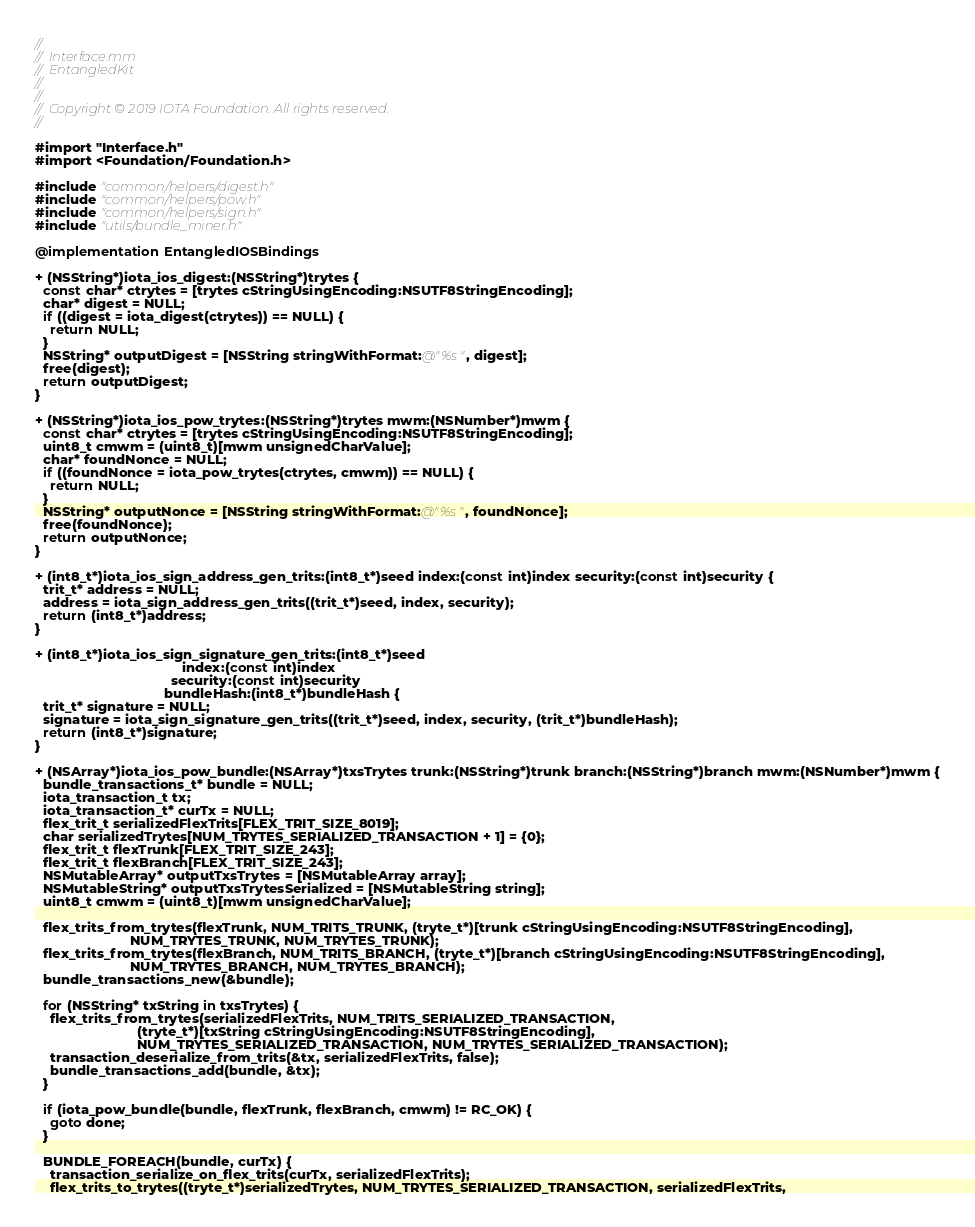<code> <loc_0><loc_0><loc_500><loc_500><_ObjectiveC_>//
//  Interface.mm
//  EntangledKit
//
//
//  Copyright © 2019 IOTA Foundation. All rights reserved.
//

#import "Interface.h"
#import <Foundation/Foundation.h>

#include "common/helpers/digest.h"
#include "common/helpers/pow.h"
#include "common/helpers/sign.h"
#include "utils/bundle_miner.h"

@implementation EntangledIOSBindings

+ (NSString*)iota_ios_digest:(NSString*)trytes {
  const char* ctrytes = [trytes cStringUsingEncoding:NSUTF8StringEncoding];
  char* digest = NULL;
  if ((digest = iota_digest(ctrytes)) == NULL) {
    return NULL;
  }
  NSString* outputDigest = [NSString stringWithFormat:@"%s", digest];
  free(digest);
  return outputDigest;
}

+ (NSString*)iota_ios_pow_trytes:(NSString*)trytes mwm:(NSNumber*)mwm {
  const char* ctrytes = [trytes cStringUsingEncoding:NSUTF8StringEncoding];
  uint8_t cmwm = (uint8_t)[mwm unsignedCharValue];
  char* foundNonce = NULL;
  if ((foundNonce = iota_pow_trytes(ctrytes, cmwm)) == NULL) {
    return NULL;
  }
  NSString* outputNonce = [NSString stringWithFormat:@"%s", foundNonce];
  free(foundNonce);
  return outputNonce;
}

+ (int8_t*)iota_ios_sign_address_gen_trits:(int8_t*)seed index:(const int)index security:(const int)security {
  trit_t* address = NULL;
  address = iota_sign_address_gen_trits((trit_t*)seed, index, security);
  return (int8_t*)address;
}

+ (int8_t*)iota_ios_sign_signature_gen_trits:(int8_t*)seed
                                       index:(const int)index
                                    security:(const int)security
                                  bundleHash:(int8_t*)bundleHash {
  trit_t* signature = NULL;
  signature = iota_sign_signature_gen_trits((trit_t*)seed, index, security, (trit_t*)bundleHash);
  return (int8_t*)signature;
}

+ (NSArray*)iota_ios_pow_bundle:(NSArray*)txsTrytes trunk:(NSString*)trunk branch:(NSString*)branch mwm:(NSNumber*)mwm {
  bundle_transactions_t* bundle = NULL;
  iota_transaction_t tx;
  iota_transaction_t* curTx = NULL;
  flex_trit_t serializedFlexTrits[FLEX_TRIT_SIZE_8019];
  char serializedTrytes[NUM_TRYTES_SERIALIZED_TRANSACTION + 1] = {0};
  flex_trit_t flexTrunk[FLEX_TRIT_SIZE_243];
  flex_trit_t flexBranch[FLEX_TRIT_SIZE_243];
  NSMutableArray* outputTxsTrytes = [NSMutableArray array];
  NSMutableString* outputTxsTrytesSerialized = [NSMutableString string];
  uint8_t cmwm = (uint8_t)[mwm unsignedCharValue];

  flex_trits_from_trytes(flexTrunk, NUM_TRITS_TRUNK, (tryte_t*)[trunk cStringUsingEncoding:NSUTF8StringEncoding],
                         NUM_TRYTES_TRUNK, NUM_TRYTES_TRUNK);
  flex_trits_from_trytes(flexBranch, NUM_TRITS_BRANCH, (tryte_t*)[branch cStringUsingEncoding:NSUTF8StringEncoding],
                         NUM_TRYTES_BRANCH, NUM_TRYTES_BRANCH);
  bundle_transactions_new(&bundle);

  for (NSString* txString in txsTrytes) {
    flex_trits_from_trytes(serializedFlexTrits, NUM_TRITS_SERIALIZED_TRANSACTION,
                           (tryte_t*)[txString cStringUsingEncoding:NSUTF8StringEncoding],
                           NUM_TRYTES_SERIALIZED_TRANSACTION, NUM_TRYTES_SERIALIZED_TRANSACTION);
    transaction_deserialize_from_trits(&tx, serializedFlexTrits, false);
    bundle_transactions_add(bundle, &tx);
  }

  if (iota_pow_bundle(bundle, flexTrunk, flexBranch, cmwm) != RC_OK) {
    goto done;
  }

  BUNDLE_FOREACH(bundle, curTx) {
    transaction_serialize_on_flex_trits(curTx, serializedFlexTrits);
    flex_trits_to_trytes((tryte_t*)serializedTrytes, NUM_TRYTES_SERIALIZED_TRANSACTION, serializedFlexTrits,</code> 